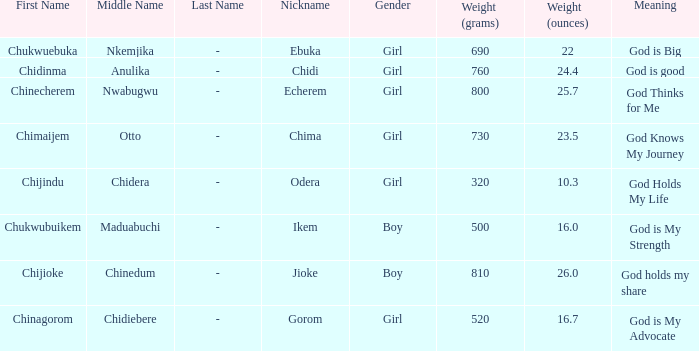What is the nickname of the baby with the birth weight of 730g (23.5 oz.)? Chima. 